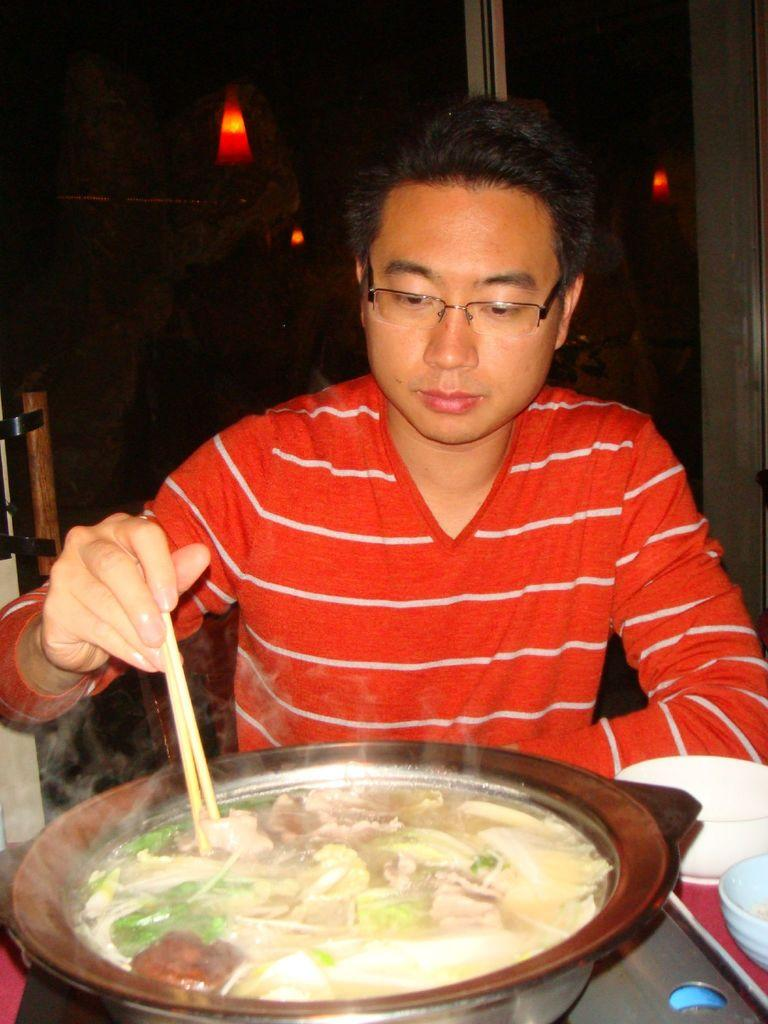Who is the person in the image? There is a man in the image. What can be seen on the man's face? The man is wearing glasses. What color is the man's t-shirt? The man is wearing a red t-shirt. What is the man holding in his right hand? The man is holding chopsticks in his right hand. What is in the bowl in the image? There is food in a bowl in the image. Who is the owner of the tent in the image? There is no tent present in the image. What page is the man reading in the image? There is no book or page visible in the image. 